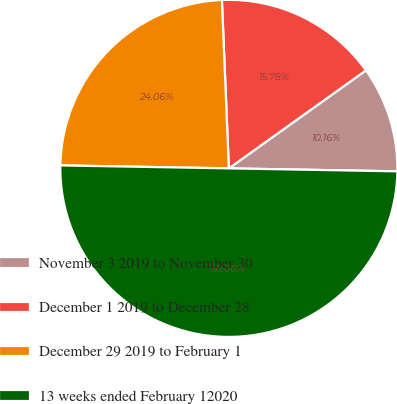<chart> <loc_0><loc_0><loc_500><loc_500><pie_chart><fcel>November 3 2019 to November 30<fcel>December 1 2019 to December 28<fcel>December 29 2019 to February 1<fcel>13 weeks ended February 12020<nl><fcel>10.16%<fcel>15.78%<fcel>24.06%<fcel>50.0%<nl></chart> 